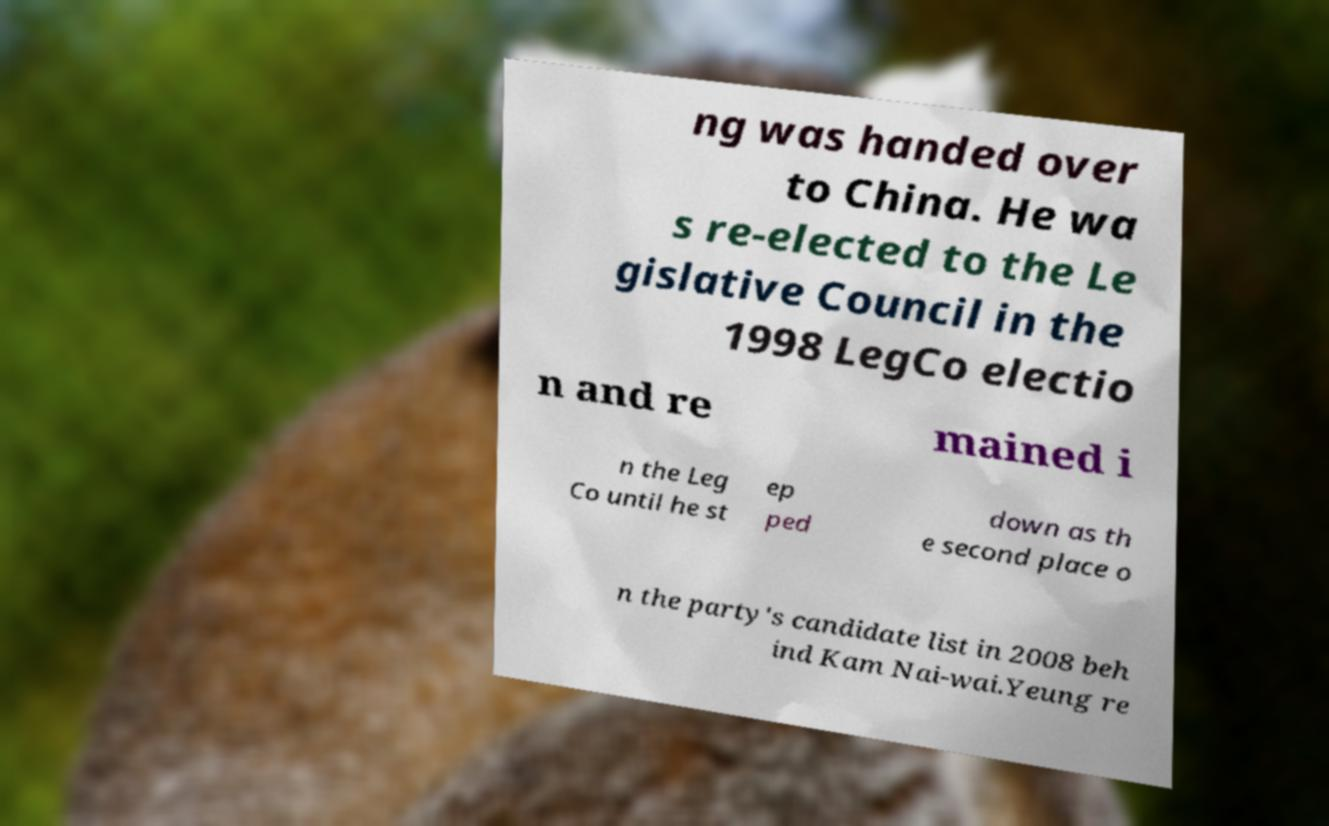Can you accurately transcribe the text from the provided image for me? ng was handed over to China. He wa s re-elected to the Le gislative Council in the 1998 LegCo electio n and re mained i n the Leg Co until he st ep ped down as th e second place o n the party's candidate list in 2008 beh ind Kam Nai-wai.Yeung re 